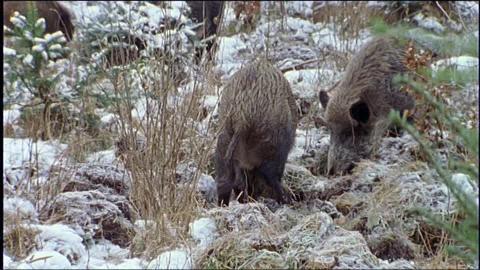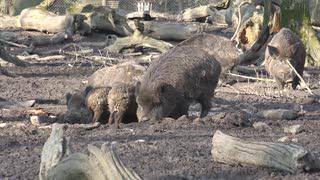The first image is the image on the left, the second image is the image on the right. For the images displayed, is the sentence "There are some piglets in the left image." factually correct? Answer yes or no. No. The first image is the image on the left, the second image is the image on the right. Examine the images to the left and right. Is the description "a warthog is standing facing the camera with piglets near her" accurate? Answer yes or no. No. 